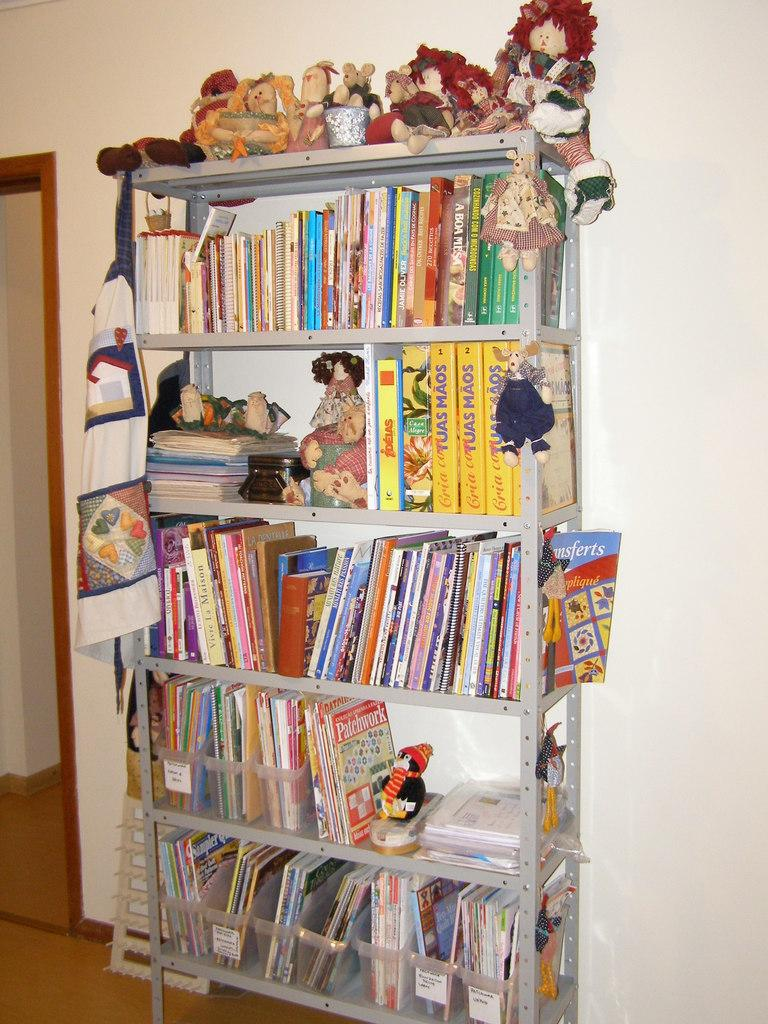What is on the rack in the image? There is a rack with books and toys in the image. What else can be seen on the rack? There is an object that looks like a bag on the rack. What is located beside the rack in the image? There is an object beside the rack in the image. What can be seen in the background of the image? There is a wall in the background of the image. Can you tell me how many cabbages are growing in the sea in the image? There are no cabbages or sea visible in the image; it features a rack with books, toys, and a bag, as well as an object beside the rack and a wall in the background. 